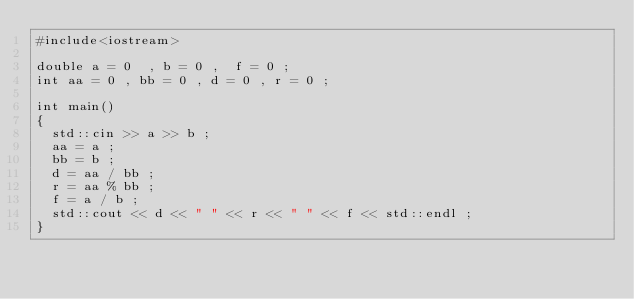<code> <loc_0><loc_0><loc_500><loc_500><_C++_>#include<iostream>

double a = 0  , b = 0 ,  f = 0 ;
int aa = 0 , bb = 0 , d = 0 , r = 0 ;

int main()
{
	std::cin >> a >> b ;
	aa = a ;
	bb = b ;
	d = aa / bb ;
	r = aa % bb ;
	f = a / b ;
	std::cout << d << " " << r << " " << f << std::endl ;
}</code> 